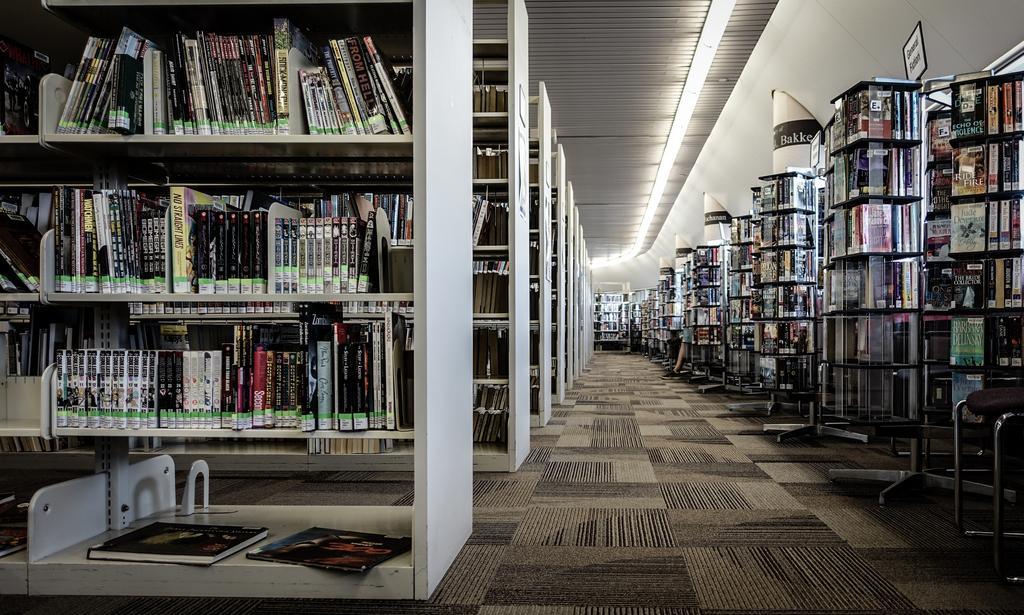Could you give a brief overview of what you see in this image? In this image we can see the inside view of a library with books on the shelves. 